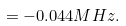<formula> <loc_0><loc_0><loc_500><loc_500>= - 0 . 0 4 4 M H z .</formula> 